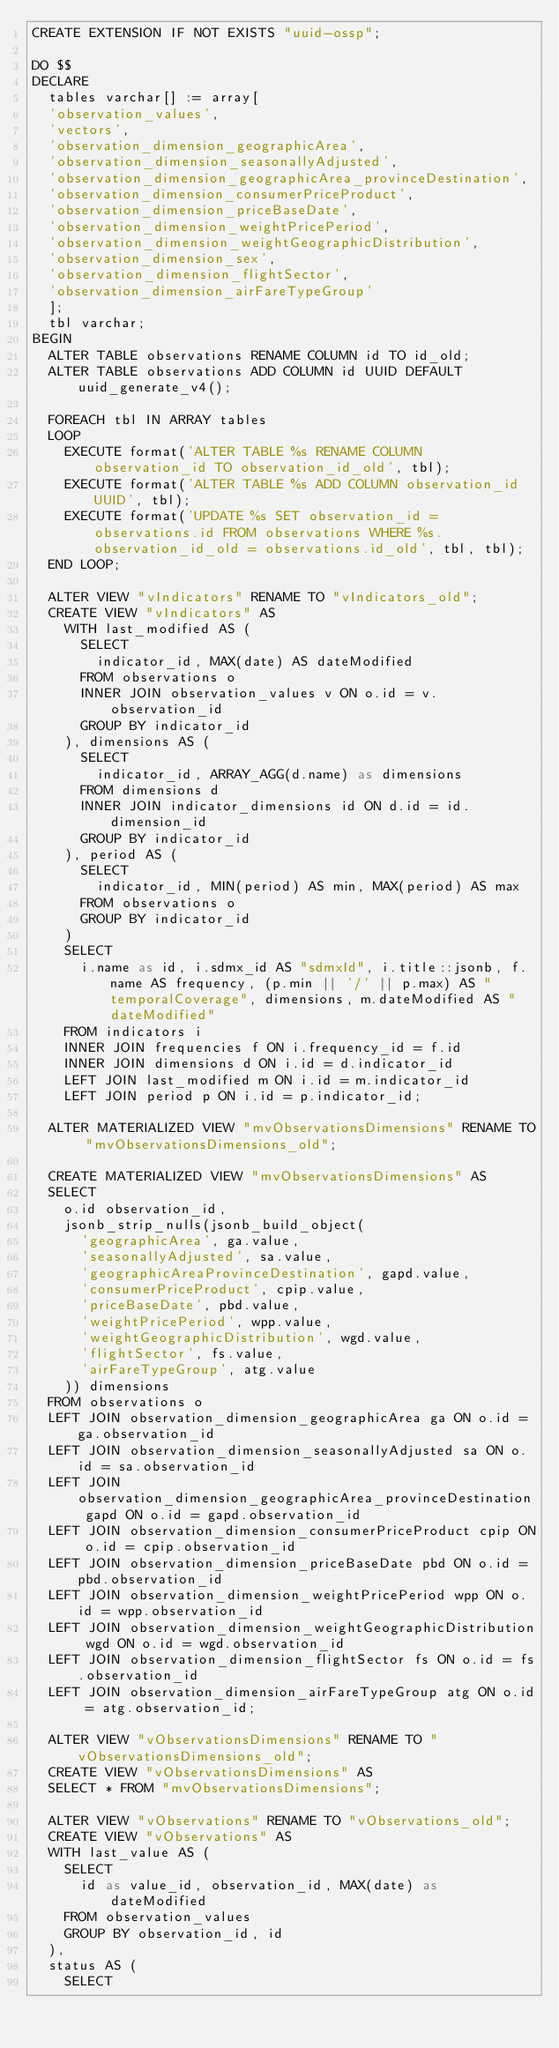Convert code to text. <code><loc_0><loc_0><loc_500><loc_500><_SQL_>CREATE EXTENSION IF NOT EXISTS "uuid-ossp";

DO $$
DECLARE
  tables varchar[] := array[
  'observation_values',
  'vectors',
  'observation_dimension_geographicArea',
  'observation_dimension_seasonallyAdjusted',
  'observation_dimension_geographicArea_provinceDestination',
  'observation_dimension_consumerPriceProduct',
  'observation_dimension_priceBaseDate',
  'observation_dimension_weightPricePeriod',
  'observation_dimension_weightGeographicDistribution',
  'observation_dimension_sex',
  'observation_dimension_flightSector',
  'observation_dimension_airFareTypeGroup'
  ];
  tbl varchar;
BEGIN
  ALTER TABLE observations RENAME COLUMN id TO id_old;
  ALTER TABLE observations ADD COLUMN id UUID DEFAULT uuid_generate_v4();

  FOREACH tbl IN ARRAY tables
  LOOP
    EXECUTE format('ALTER TABLE %s RENAME COLUMN observation_id TO observation_id_old', tbl);
    EXECUTE format('ALTER TABLE %s ADD COLUMN observation_id UUID', tbl);
    EXECUTE format('UPDATE %s SET observation_id = observations.id FROM observations WHERE %s.observation_id_old = observations.id_old', tbl, tbl);
  END LOOP;

  ALTER VIEW "vIndicators" RENAME TO "vIndicators_old";
  CREATE VIEW "vIndicators" AS
    WITH last_modified AS (
      SELECT
        indicator_id, MAX(date) AS dateModified
      FROM observations o
      INNER JOIN observation_values v ON o.id = v.observation_id
      GROUP BY indicator_id
    ), dimensions AS (
      SELECT
        indicator_id, ARRAY_AGG(d.name) as dimensions
      FROM dimensions d
      INNER JOIN indicator_dimensions id ON d.id = id.dimension_id
      GROUP BY indicator_id
    ), period AS (
      SELECT
        indicator_id, MIN(period) AS min, MAX(period) AS max
      FROM observations o
      GROUP BY indicator_id
    )
    SELECT
      i.name as id, i.sdmx_id AS "sdmxId", i.title::jsonb, f.name AS frequency, (p.min || '/' || p.max) AS "temporalCoverage", dimensions, m.dateModified AS "dateModified"
    FROM indicators i
    INNER JOIN frequencies f ON i.frequency_id = f.id
    INNER JOIN dimensions d ON i.id = d.indicator_id
    LEFT JOIN last_modified m ON i.id = m.indicator_id
    LEFT JOIN period p ON i.id = p.indicator_id;

  ALTER MATERIALIZED VIEW "mvObservationsDimensions" RENAME TO "mvObservationsDimensions_old";

  CREATE MATERIALIZED VIEW "mvObservationsDimensions" AS
  SELECT
    o.id observation_id,
    jsonb_strip_nulls(jsonb_build_object(
      'geographicArea', ga.value,
      'seasonallyAdjusted', sa.value,
      'geographicAreaProvinceDestination', gapd.value,
      'consumerPriceProduct', cpip.value,
      'priceBaseDate', pbd.value,
      'weightPricePeriod', wpp.value,
      'weightGeographicDistribution', wgd.value,
      'flightSector', fs.value,
      'airFareTypeGroup', atg.value
    )) dimensions
  FROM observations o
  LEFT JOIN observation_dimension_geographicArea ga ON o.id = ga.observation_id
  LEFT JOIN observation_dimension_seasonallyAdjusted sa ON o.id = sa.observation_id
  LEFT JOIN observation_dimension_geographicArea_provinceDestination gapd ON o.id = gapd.observation_id
  LEFT JOIN observation_dimension_consumerPriceProduct cpip ON o.id = cpip.observation_id
  LEFT JOIN observation_dimension_priceBaseDate pbd ON o.id = pbd.observation_id
  LEFT JOIN observation_dimension_weightPricePeriod wpp ON o.id = wpp.observation_id
  LEFT JOIN observation_dimension_weightGeographicDistribution wgd ON o.id = wgd.observation_id
  LEFT JOIN observation_dimension_flightSector fs ON o.id = fs.observation_id
  LEFT JOIN observation_dimension_airFareTypeGroup atg ON o.id = atg.observation_id;

  ALTER VIEW "vObservationsDimensions" RENAME TO "vObservationsDimensions_old";
  CREATE VIEW "vObservationsDimensions" AS
  SELECT * FROM "mvObservationsDimensions";

  ALTER VIEW "vObservations" RENAME TO "vObservations_old";
  CREATE VIEW "vObservations" AS
  WITH last_value AS (
    SELECT
      id as value_id, observation_id, MAX(date) as dateModified
    FROM observation_values
    GROUP BY observation_id, id
  ),
  status AS (
    SELECT</code> 